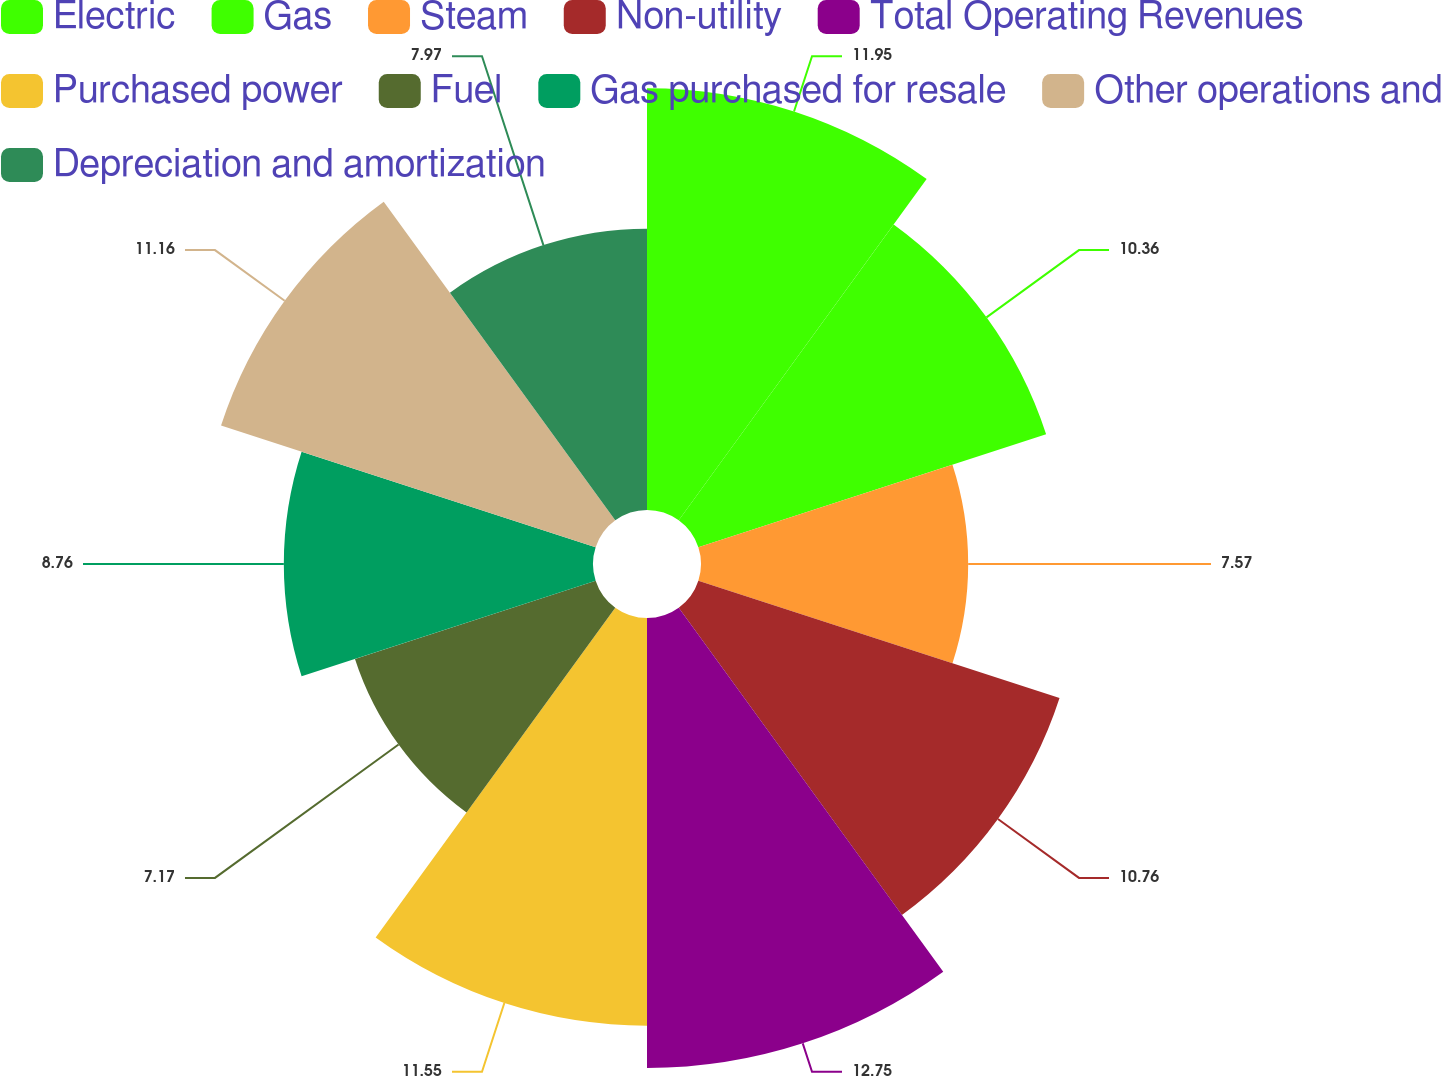Convert chart to OTSL. <chart><loc_0><loc_0><loc_500><loc_500><pie_chart><fcel>Electric<fcel>Gas<fcel>Steam<fcel>Non-utility<fcel>Total Operating Revenues<fcel>Purchased power<fcel>Fuel<fcel>Gas purchased for resale<fcel>Other operations and<fcel>Depreciation and amortization<nl><fcel>11.95%<fcel>10.36%<fcel>7.57%<fcel>10.76%<fcel>12.75%<fcel>11.55%<fcel>7.17%<fcel>8.76%<fcel>11.16%<fcel>7.97%<nl></chart> 